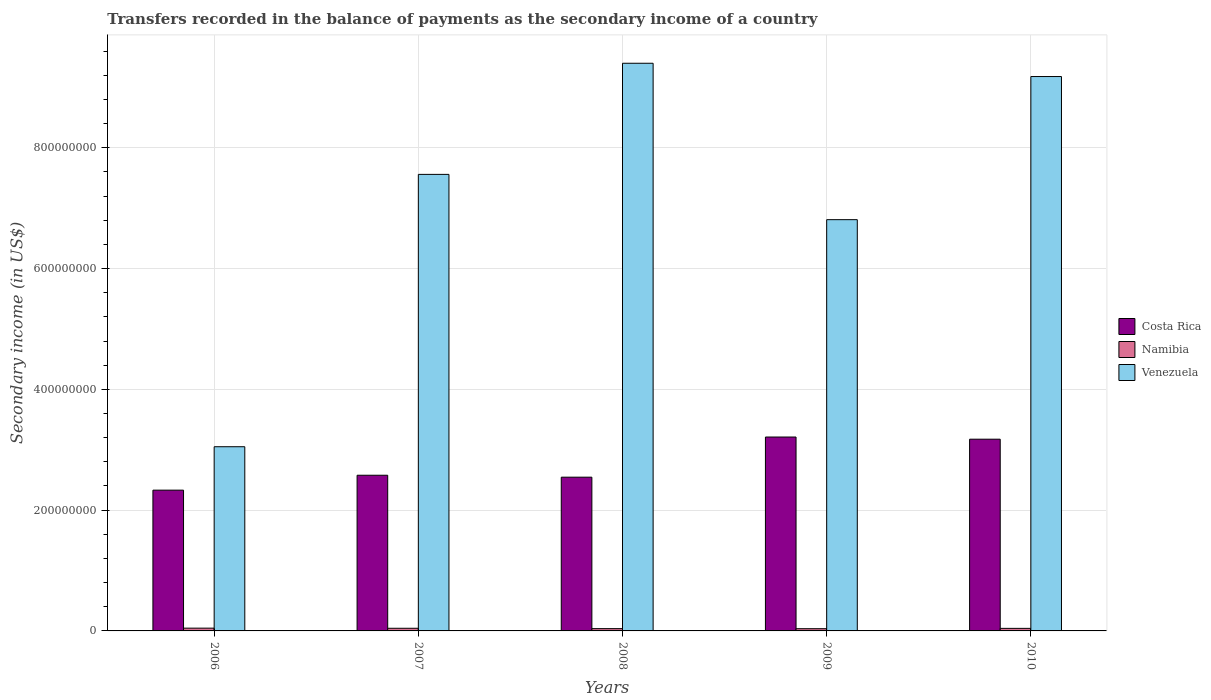Are the number of bars per tick equal to the number of legend labels?
Your answer should be very brief. Yes. How many bars are there on the 4th tick from the right?
Your response must be concise. 3. What is the label of the 3rd group of bars from the left?
Offer a very short reply. 2008. In how many cases, is the number of bars for a given year not equal to the number of legend labels?
Provide a succinct answer. 0. What is the secondary income of in Costa Rica in 2008?
Offer a very short reply. 2.55e+08. Across all years, what is the maximum secondary income of in Costa Rica?
Your answer should be compact. 3.21e+08. Across all years, what is the minimum secondary income of in Costa Rica?
Give a very brief answer. 2.33e+08. In which year was the secondary income of in Costa Rica maximum?
Provide a succinct answer. 2009. In which year was the secondary income of in Namibia minimum?
Your answer should be compact. 2009. What is the total secondary income of in Costa Rica in the graph?
Make the answer very short. 1.38e+09. What is the difference between the secondary income of in Namibia in 2008 and that in 2010?
Give a very brief answer. -4.39e+05. What is the difference between the secondary income of in Namibia in 2007 and the secondary income of in Costa Rica in 2008?
Give a very brief answer. -2.50e+08. What is the average secondary income of in Costa Rica per year?
Give a very brief answer. 2.77e+08. In the year 2007, what is the difference between the secondary income of in Costa Rica and secondary income of in Namibia?
Offer a terse response. 2.53e+08. In how many years, is the secondary income of in Costa Rica greater than 800000000 US$?
Make the answer very short. 0. What is the ratio of the secondary income of in Venezuela in 2006 to that in 2008?
Provide a succinct answer. 0.32. Is the secondary income of in Costa Rica in 2007 less than that in 2009?
Ensure brevity in your answer.  Yes. What is the difference between the highest and the second highest secondary income of in Namibia?
Your answer should be compact. 1.97e+05. What is the difference between the highest and the lowest secondary income of in Venezuela?
Make the answer very short. 6.35e+08. Is the sum of the secondary income of in Costa Rica in 2009 and 2010 greater than the maximum secondary income of in Venezuela across all years?
Ensure brevity in your answer.  No. What does the 2nd bar from the left in 2009 represents?
Offer a terse response. Namibia. What does the 2nd bar from the right in 2006 represents?
Your answer should be very brief. Namibia. How many bars are there?
Make the answer very short. 15. Are the values on the major ticks of Y-axis written in scientific E-notation?
Your answer should be very brief. No. Does the graph contain any zero values?
Make the answer very short. No. Does the graph contain grids?
Your answer should be compact. Yes. Where does the legend appear in the graph?
Your answer should be compact. Center right. How many legend labels are there?
Make the answer very short. 3. What is the title of the graph?
Provide a succinct answer. Transfers recorded in the balance of payments as the secondary income of a country. Does "Oman" appear as one of the legend labels in the graph?
Keep it short and to the point. No. What is the label or title of the X-axis?
Your response must be concise. Years. What is the label or title of the Y-axis?
Give a very brief answer. Secondary income (in US$). What is the Secondary income (in US$) of Costa Rica in 2006?
Provide a succinct answer. 2.33e+08. What is the Secondary income (in US$) in Namibia in 2006?
Your answer should be very brief. 4.58e+06. What is the Secondary income (in US$) of Venezuela in 2006?
Your answer should be very brief. 3.05e+08. What is the Secondary income (in US$) of Costa Rica in 2007?
Your answer should be compact. 2.58e+08. What is the Secondary income (in US$) of Namibia in 2007?
Give a very brief answer. 4.39e+06. What is the Secondary income (in US$) of Venezuela in 2007?
Provide a short and direct response. 7.56e+08. What is the Secondary income (in US$) of Costa Rica in 2008?
Your answer should be compact. 2.55e+08. What is the Secondary income (in US$) in Namibia in 2008?
Your answer should be compact. 3.78e+06. What is the Secondary income (in US$) of Venezuela in 2008?
Offer a terse response. 9.40e+08. What is the Secondary income (in US$) in Costa Rica in 2009?
Provide a succinct answer. 3.21e+08. What is the Secondary income (in US$) of Namibia in 2009?
Offer a terse response. 3.69e+06. What is the Secondary income (in US$) of Venezuela in 2009?
Ensure brevity in your answer.  6.81e+08. What is the Secondary income (in US$) of Costa Rica in 2010?
Your response must be concise. 3.17e+08. What is the Secondary income (in US$) of Namibia in 2010?
Give a very brief answer. 4.22e+06. What is the Secondary income (in US$) in Venezuela in 2010?
Provide a succinct answer. 9.18e+08. Across all years, what is the maximum Secondary income (in US$) of Costa Rica?
Offer a terse response. 3.21e+08. Across all years, what is the maximum Secondary income (in US$) in Namibia?
Your response must be concise. 4.58e+06. Across all years, what is the maximum Secondary income (in US$) in Venezuela?
Make the answer very short. 9.40e+08. Across all years, what is the minimum Secondary income (in US$) of Costa Rica?
Your response must be concise. 2.33e+08. Across all years, what is the minimum Secondary income (in US$) of Namibia?
Keep it short and to the point. 3.69e+06. Across all years, what is the minimum Secondary income (in US$) in Venezuela?
Provide a short and direct response. 3.05e+08. What is the total Secondary income (in US$) of Costa Rica in the graph?
Ensure brevity in your answer.  1.38e+09. What is the total Secondary income (in US$) of Namibia in the graph?
Ensure brevity in your answer.  2.07e+07. What is the total Secondary income (in US$) in Venezuela in the graph?
Your response must be concise. 3.60e+09. What is the difference between the Secondary income (in US$) of Costa Rica in 2006 and that in 2007?
Provide a succinct answer. -2.47e+07. What is the difference between the Secondary income (in US$) of Namibia in 2006 and that in 2007?
Provide a succinct answer. 1.97e+05. What is the difference between the Secondary income (in US$) of Venezuela in 2006 and that in 2007?
Provide a short and direct response. -4.51e+08. What is the difference between the Secondary income (in US$) of Costa Rica in 2006 and that in 2008?
Offer a very short reply. -2.15e+07. What is the difference between the Secondary income (in US$) in Namibia in 2006 and that in 2008?
Give a very brief answer. 7.98e+05. What is the difference between the Secondary income (in US$) in Venezuela in 2006 and that in 2008?
Your answer should be very brief. -6.35e+08. What is the difference between the Secondary income (in US$) in Costa Rica in 2006 and that in 2009?
Offer a terse response. -8.80e+07. What is the difference between the Secondary income (in US$) of Namibia in 2006 and that in 2009?
Your response must be concise. 8.89e+05. What is the difference between the Secondary income (in US$) of Venezuela in 2006 and that in 2009?
Provide a succinct answer. -3.76e+08. What is the difference between the Secondary income (in US$) of Costa Rica in 2006 and that in 2010?
Offer a terse response. -8.44e+07. What is the difference between the Secondary income (in US$) of Namibia in 2006 and that in 2010?
Keep it short and to the point. 3.60e+05. What is the difference between the Secondary income (in US$) in Venezuela in 2006 and that in 2010?
Offer a very short reply. -6.13e+08. What is the difference between the Secondary income (in US$) of Costa Rica in 2007 and that in 2008?
Make the answer very short. 3.20e+06. What is the difference between the Secondary income (in US$) in Namibia in 2007 and that in 2008?
Offer a very short reply. 6.01e+05. What is the difference between the Secondary income (in US$) of Venezuela in 2007 and that in 2008?
Ensure brevity in your answer.  -1.84e+08. What is the difference between the Secondary income (in US$) in Costa Rica in 2007 and that in 2009?
Your answer should be compact. -6.33e+07. What is the difference between the Secondary income (in US$) of Namibia in 2007 and that in 2009?
Make the answer very short. 6.93e+05. What is the difference between the Secondary income (in US$) in Venezuela in 2007 and that in 2009?
Provide a succinct answer. 7.50e+07. What is the difference between the Secondary income (in US$) in Costa Rica in 2007 and that in 2010?
Offer a terse response. -5.97e+07. What is the difference between the Secondary income (in US$) of Namibia in 2007 and that in 2010?
Your answer should be compact. 1.63e+05. What is the difference between the Secondary income (in US$) of Venezuela in 2007 and that in 2010?
Provide a short and direct response. -1.62e+08. What is the difference between the Secondary income (in US$) in Costa Rica in 2008 and that in 2009?
Make the answer very short. -6.65e+07. What is the difference between the Secondary income (in US$) in Namibia in 2008 and that in 2009?
Your answer should be very brief. 9.12e+04. What is the difference between the Secondary income (in US$) of Venezuela in 2008 and that in 2009?
Your answer should be very brief. 2.59e+08. What is the difference between the Secondary income (in US$) of Costa Rica in 2008 and that in 2010?
Ensure brevity in your answer.  -6.29e+07. What is the difference between the Secondary income (in US$) of Namibia in 2008 and that in 2010?
Give a very brief answer. -4.39e+05. What is the difference between the Secondary income (in US$) of Venezuela in 2008 and that in 2010?
Provide a succinct answer. 2.20e+07. What is the difference between the Secondary income (in US$) in Costa Rica in 2009 and that in 2010?
Make the answer very short. 3.59e+06. What is the difference between the Secondary income (in US$) of Namibia in 2009 and that in 2010?
Your answer should be compact. -5.30e+05. What is the difference between the Secondary income (in US$) in Venezuela in 2009 and that in 2010?
Offer a terse response. -2.37e+08. What is the difference between the Secondary income (in US$) in Costa Rica in 2006 and the Secondary income (in US$) in Namibia in 2007?
Your answer should be compact. 2.29e+08. What is the difference between the Secondary income (in US$) of Costa Rica in 2006 and the Secondary income (in US$) of Venezuela in 2007?
Give a very brief answer. -5.23e+08. What is the difference between the Secondary income (in US$) in Namibia in 2006 and the Secondary income (in US$) in Venezuela in 2007?
Offer a terse response. -7.51e+08. What is the difference between the Secondary income (in US$) of Costa Rica in 2006 and the Secondary income (in US$) of Namibia in 2008?
Provide a short and direct response. 2.29e+08. What is the difference between the Secondary income (in US$) of Costa Rica in 2006 and the Secondary income (in US$) of Venezuela in 2008?
Offer a very short reply. -7.07e+08. What is the difference between the Secondary income (in US$) in Namibia in 2006 and the Secondary income (in US$) in Venezuela in 2008?
Keep it short and to the point. -9.35e+08. What is the difference between the Secondary income (in US$) of Costa Rica in 2006 and the Secondary income (in US$) of Namibia in 2009?
Ensure brevity in your answer.  2.29e+08. What is the difference between the Secondary income (in US$) in Costa Rica in 2006 and the Secondary income (in US$) in Venezuela in 2009?
Make the answer very short. -4.48e+08. What is the difference between the Secondary income (in US$) of Namibia in 2006 and the Secondary income (in US$) of Venezuela in 2009?
Ensure brevity in your answer.  -6.76e+08. What is the difference between the Secondary income (in US$) of Costa Rica in 2006 and the Secondary income (in US$) of Namibia in 2010?
Keep it short and to the point. 2.29e+08. What is the difference between the Secondary income (in US$) of Costa Rica in 2006 and the Secondary income (in US$) of Venezuela in 2010?
Your answer should be very brief. -6.85e+08. What is the difference between the Secondary income (in US$) of Namibia in 2006 and the Secondary income (in US$) of Venezuela in 2010?
Ensure brevity in your answer.  -9.13e+08. What is the difference between the Secondary income (in US$) in Costa Rica in 2007 and the Secondary income (in US$) in Namibia in 2008?
Offer a very short reply. 2.54e+08. What is the difference between the Secondary income (in US$) of Costa Rica in 2007 and the Secondary income (in US$) of Venezuela in 2008?
Ensure brevity in your answer.  -6.82e+08. What is the difference between the Secondary income (in US$) of Namibia in 2007 and the Secondary income (in US$) of Venezuela in 2008?
Make the answer very short. -9.36e+08. What is the difference between the Secondary income (in US$) of Costa Rica in 2007 and the Secondary income (in US$) of Namibia in 2009?
Keep it short and to the point. 2.54e+08. What is the difference between the Secondary income (in US$) in Costa Rica in 2007 and the Secondary income (in US$) in Venezuela in 2009?
Give a very brief answer. -4.23e+08. What is the difference between the Secondary income (in US$) of Namibia in 2007 and the Secondary income (in US$) of Venezuela in 2009?
Keep it short and to the point. -6.77e+08. What is the difference between the Secondary income (in US$) of Costa Rica in 2007 and the Secondary income (in US$) of Namibia in 2010?
Provide a short and direct response. 2.54e+08. What is the difference between the Secondary income (in US$) of Costa Rica in 2007 and the Secondary income (in US$) of Venezuela in 2010?
Ensure brevity in your answer.  -6.60e+08. What is the difference between the Secondary income (in US$) of Namibia in 2007 and the Secondary income (in US$) of Venezuela in 2010?
Make the answer very short. -9.14e+08. What is the difference between the Secondary income (in US$) of Costa Rica in 2008 and the Secondary income (in US$) of Namibia in 2009?
Ensure brevity in your answer.  2.51e+08. What is the difference between the Secondary income (in US$) in Costa Rica in 2008 and the Secondary income (in US$) in Venezuela in 2009?
Give a very brief answer. -4.26e+08. What is the difference between the Secondary income (in US$) in Namibia in 2008 and the Secondary income (in US$) in Venezuela in 2009?
Provide a succinct answer. -6.77e+08. What is the difference between the Secondary income (in US$) of Costa Rica in 2008 and the Secondary income (in US$) of Namibia in 2010?
Provide a short and direct response. 2.50e+08. What is the difference between the Secondary income (in US$) of Costa Rica in 2008 and the Secondary income (in US$) of Venezuela in 2010?
Offer a very short reply. -6.63e+08. What is the difference between the Secondary income (in US$) in Namibia in 2008 and the Secondary income (in US$) in Venezuela in 2010?
Offer a terse response. -9.14e+08. What is the difference between the Secondary income (in US$) in Costa Rica in 2009 and the Secondary income (in US$) in Namibia in 2010?
Your response must be concise. 3.17e+08. What is the difference between the Secondary income (in US$) in Costa Rica in 2009 and the Secondary income (in US$) in Venezuela in 2010?
Make the answer very short. -5.97e+08. What is the difference between the Secondary income (in US$) in Namibia in 2009 and the Secondary income (in US$) in Venezuela in 2010?
Your answer should be compact. -9.14e+08. What is the average Secondary income (in US$) of Costa Rica per year?
Make the answer very short. 2.77e+08. What is the average Secondary income (in US$) of Namibia per year?
Your answer should be compact. 4.13e+06. What is the average Secondary income (in US$) of Venezuela per year?
Provide a succinct answer. 7.20e+08. In the year 2006, what is the difference between the Secondary income (in US$) of Costa Rica and Secondary income (in US$) of Namibia?
Provide a succinct answer. 2.29e+08. In the year 2006, what is the difference between the Secondary income (in US$) in Costa Rica and Secondary income (in US$) in Venezuela?
Your answer should be compact. -7.19e+07. In the year 2006, what is the difference between the Secondary income (in US$) in Namibia and Secondary income (in US$) in Venezuela?
Provide a succinct answer. -3.00e+08. In the year 2007, what is the difference between the Secondary income (in US$) of Costa Rica and Secondary income (in US$) of Namibia?
Offer a terse response. 2.53e+08. In the year 2007, what is the difference between the Secondary income (in US$) in Costa Rica and Secondary income (in US$) in Venezuela?
Your answer should be very brief. -4.98e+08. In the year 2007, what is the difference between the Secondary income (in US$) of Namibia and Secondary income (in US$) of Venezuela?
Give a very brief answer. -7.52e+08. In the year 2008, what is the difference between the Secondary income (in US$) in Costa Rica and Secondary income (in US$) in Namibia?
Your answer should be compact. 2.51e+08. In the year 2008, what is the difference between the Secondary income (in US$) in Costa Rica and Secondary income (in US$) in Venezuela?
Offer a very short reply. -6.85e+08. In the year 2008, what is the difference between the Secondary income (in US$) of Namibia and Secondary income (in US$) of Venezuela?
Your answer should be compact. -9.36e+08. In the year 2009, what is the difference between the Secondary income (in US$) of Costa Rica and Secondary income (in US$) of Namibia?
Your response must be concise. 3.17e+08. In the year 2009, what is the difference between the Secondary income (in US$) in Costa Rica and Secondary income (in US$) in Venezuela?
Give a very brief answer. -3.60e+08. In the year 2009, what is the difference between the Secondary income (in US$) of Namibia and Secondary income (in US$) of Venezuela?
Keep it short and to the point. -6.77e+08. In the year 2010, what is the difference between the Secondary income (in US$) of Costa Rica and Secondary income (in US$) of Namibia?
Offer a terse response. 3.13e+08. In the year 2010, what is the difference between the Secondary income (in US$) of Costa Rica and Secondary income (in US$) of Venezuela?
Provide a short and direct response. -6.01e+08. In the year 2010, what is the difference between the Secondary income (in US$) of Namibia and Secondary income (in US$) of Venezuela?
Your response must be concise. -9.14e+08. What is the ratio of the Secondary income (in US$) of Costa Rica in 2006 to that in 2007?
Provide a succinct answer. 0.9. What is the ratio of the Secondary income (in US$) in Namibia in 2006 to that in 2007?
Your answer should be compact. 1.04. What is the ratio of the Secondary income (in US$) of Venezuela in 2006 to that in 2007?
Ensure brevity in your answer.  0.4. What is the ratio of the Secondary income (in US$) of Costa Rica in 2006 to that in 2008?
Ensure brevity in your answer.  0.92. What is the ratio of the Secondary income (in US$) in Namibia in 2006 to that in 2008?
Keep it short and to the point. 1.21. What is the ratio of the Secondary income (in US$) of Venezuela in 2006 to that in 2008?
Provide a succinct answer. 0.32. What is the ratio of the Secondary income (in US$) in Costa Rica in 2006 to that in 2009?
Your answer should be very brief. 0.73. What is the ratio of the Secondary income (in US$) in Namibia in 2006 to that in 2009?
Your answer should be very brief. 1.24. What is the ratio of the Secondary income (in US$) of Venezuela in 2006 to that in 2009?
Your answer should be compact. 0.45. What is the ratio of the Secondary income (in US$) of Costa Rica in 2006 to that in 2010?
Your answer should be compact. 0.73. What is the ratio of the Secondary income (in US$) of Namibia in 2006 to that in 2010?
Your response must be concise. 1.09. What is the ratio of the Secondary income (in US$) in Venezuela in 2006 to that in 2010?
Give a very brief answer. 0.33. What is the ratio of the Secondary income (in US$) in Costa Rica in 2007 to that in 2008?
Offer a very short reply. 1.01. What is the ratio of the Secondary income (in US$) in Namibia in 2007 to that in 2008?
Offer a very short reply. 1.16. What is the ratio of the Secondary income (in US$) in Venezuela in 2007 to that in 2008?
Offer a very short reply. 0.8. What is the ratio of the Secondary income (in US$) in Costa Rica in 2007 to that in 2009?
Offer a terse response. 0.8. What is the ratio of the Secondary income (in US$) in Namibia in 2007 to that in 2009?
Make the answer very short. 1.19. What is the ratio of the Secondary income (in US$) in Venezuela in 2007 to that in 2009?
Keep it short and to the point. 1.11. What is the ratio of the Secondary income (in US$) in Costa Rica in 2007 to that in 2010?
Provide a succinct answer. 0.81. What is the ratio of the Secondary income (in US$) in Venezuela in 2007 to that in 2010?
Provide a succinct answer. 0.82. What is the ratio of the Secondary income (in US$) in Costa Rica in 2008 to that in 2009?
Keep it short and to the point. 0.79. What is the ratio of the Secondary income (in US$) of Namibia in 2008 to that in 2009?
Keep it short and to the point. 1.02. What is the ratio of the Secondary income (in US$) in Venezuela in 2008 to that in 2009?
Offer a very short reply. 1.38. What is the ratio of the Secondary income (in US$) of Costa Rica in 2008 to that in 2010?
Your answer should be compact. 0.8. What is the ratio of the Secondary income (in US$) of Namibia in 2008 to that in 2010?
Give a very brief answer. 0.9. What is the ratio of the Secondary income (in US$) in Venezuela in 2008 to that in 2010?
Offer a very short reply. 1.02. What is the ratio of the Secondary income (in US$) in Costa Rica in 2009 to that in 2010?
Provide a succinct answer. 1.01. What is the ratio of the Secondary income (in US$) of Namibia in 2009 to that in 2010?
Offer a very short reply. 0.87. What is the ratio of the Secondary income (in US$) in Venezuela in 2009 to that in 2010?
Offer a very short reply. 0.74. What is the difference between the highest and the second highest Secondary income (in US$) of Costa Rica?
Offer a very short reply. 3.59e+06. What is the difference between the highest and the second highest Secondary income (in US$) of Namibia?
Make the answer very short. 1.97e+05. What is the difference between the highest and the second highest Secondary income (in US$) of Venezuela?
Offer a very short reply. 2.20e+07. What is the difference between the highest and the lowest Secondary income (in US$) of Costa Rica?
Offer a very short reply. 8.80e+07. What is the difference between the highest and the lowest Secondary income (in US$) in Namibia?
Offer a very short reply. 8.89e+05. What is the difference between the highest and the lowest Secondary income (in US$) in Venezuela?
Make the answer very short. 6.35e+08. 